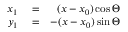Convert formula to latex. <formula><loc_0><loc_0><loc_500><loc_500>\begin{array} { r l r } { x _ { 1 } } & = } & { ( x - x _ { 0 } ) \cos \Theta } \\ { y _ { 1 } } & = } & { - ( x - x _ { 0 } ) \sin \Theta } \end{array}</formula> 